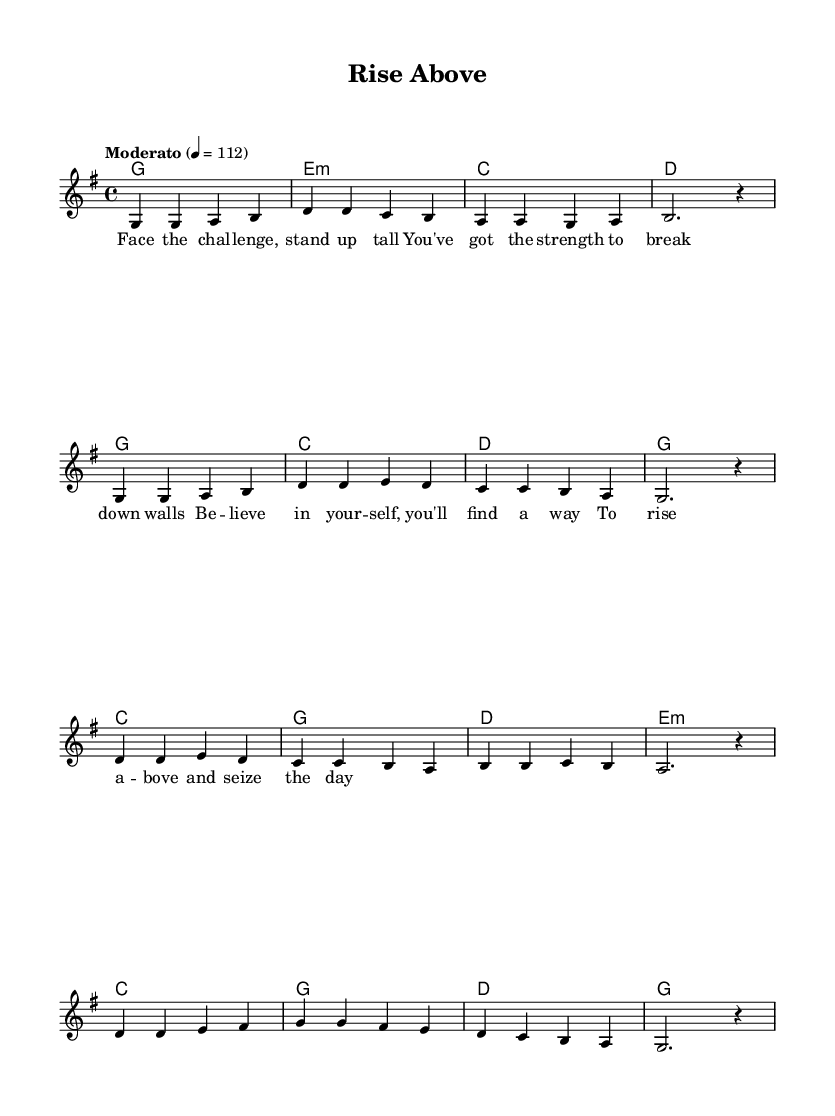What is the key signature of this music? The key signature is G major, which has one sharp (F#). This can be determined by examining the key signature section in the upper left corner of the sheet music.
Answer: G major What is the time signature of this piece? The time signature is 4/4, meaning there are four beats in each measure and the quarter note gets one beat. This is indicated at the beginning of the staff, right after the key signature.
Answer: 4/4 What is the tempo marking for the piece? The tempo marking is "Moderato" and indicates a moderate speed of 112 beats per minute. This information is typically found above the staff, indicating how fast the music should be played.
Answer: Moderato How many measures are there in the melody section? There are 12 measures in the melody section. By counting the groups of notes and vertical lines separating the measures, one can determine the total number of measures present.
Answer: 12 What is the last chord in the progression? The last chord in the progression is G. This can be identified by looking at the chord names written above the melody, and finding the final chord symbol at the end of the harmonic progression.
Answer: G How does the melody begin in terms of note pitch? The melody begins with the note G. This can be found by observing the first note of the melody line as represented on the staff.
Answer: G What is the lyrical message of the song about? The song conveys a message of perseverance and self-belief in overcoming challenges. This can be inferred from the lyrics that encourage facing challenges and seizing the day, indicated in the lyric section of the sheet music.
Answer: Perseverance 